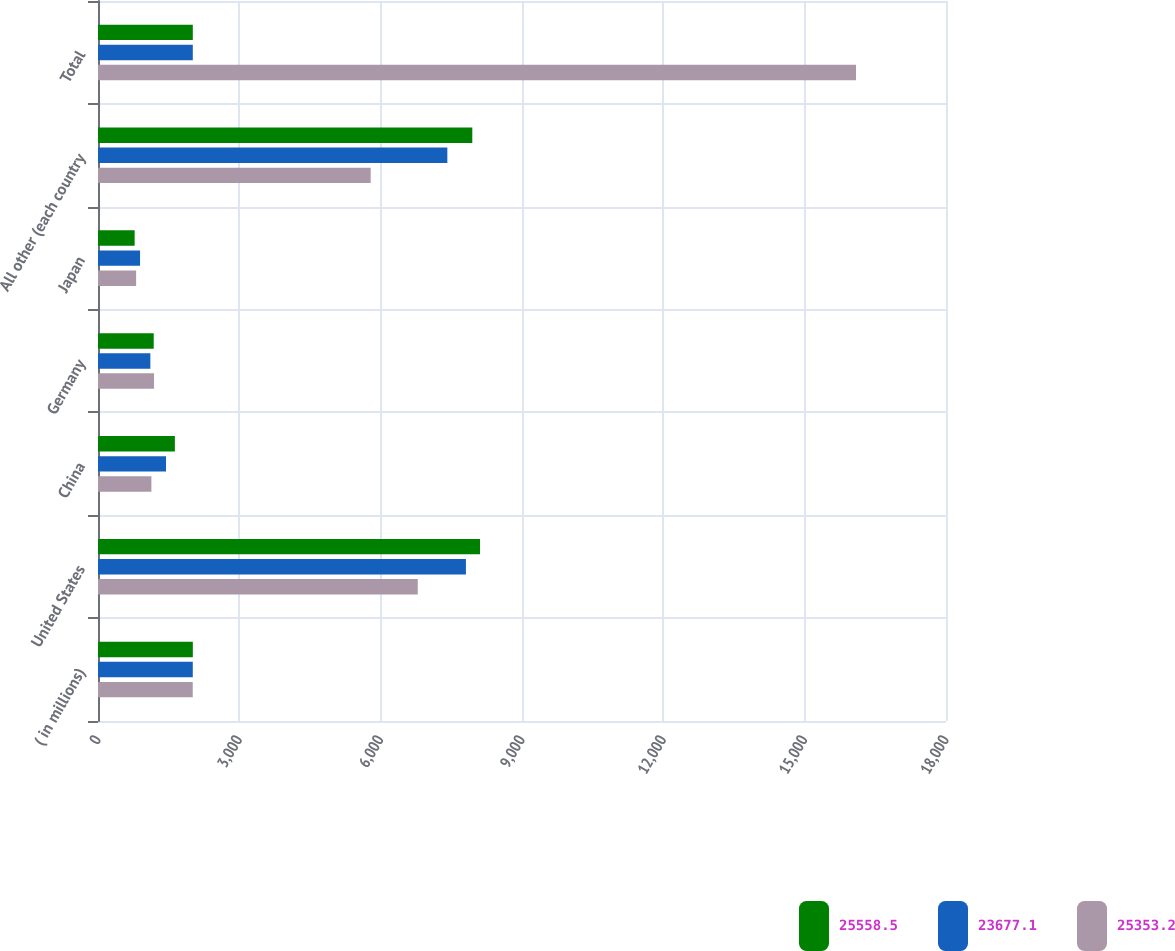Convert chart. <chart><loc_0><loc_0><loc_500><loc_500><stacked_bar_chart><ecel><fcel>( in millions)<fcel>United States<fcel>China<fcel>Germany<fcel>Japan<fcel>All other (each country<fcel>Total<nl><fcel>25558.5<fcel>2013<fcel>8109.3<fcel>1631.8<fcel>1182.8<fcel>777.7<fcel>7945.1<fcel>2012.5<nl><fcel>23677.1<fcel>2012<fcel>7809.8<fcel>1443.5<fcel>1111.3<fcel>892.8<fcel>7415.3<fcel>2012.5<nl><fcel>25353.2<fcel>2011<fcel>6787.8<fcel>1133.2<fcel>1189<fcel>809.4<fcel>5788.3<fcel>16090.5<nl></chart> 